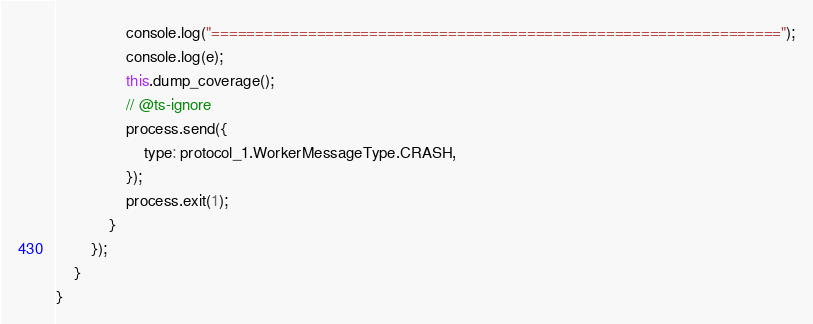Convert code to text. <code><loc_0><loc_0><loc_500><loc_500><_JavaScript_>                console.log("=================================================================");
                console.log(e);
                this.dump_coverage();
                // @ts-ignore
                process.send({
                    type: protocol_1.WorkerMessageType.CRASH,
                });
                process.exit(1);
            }
        });
    }
}</code> 